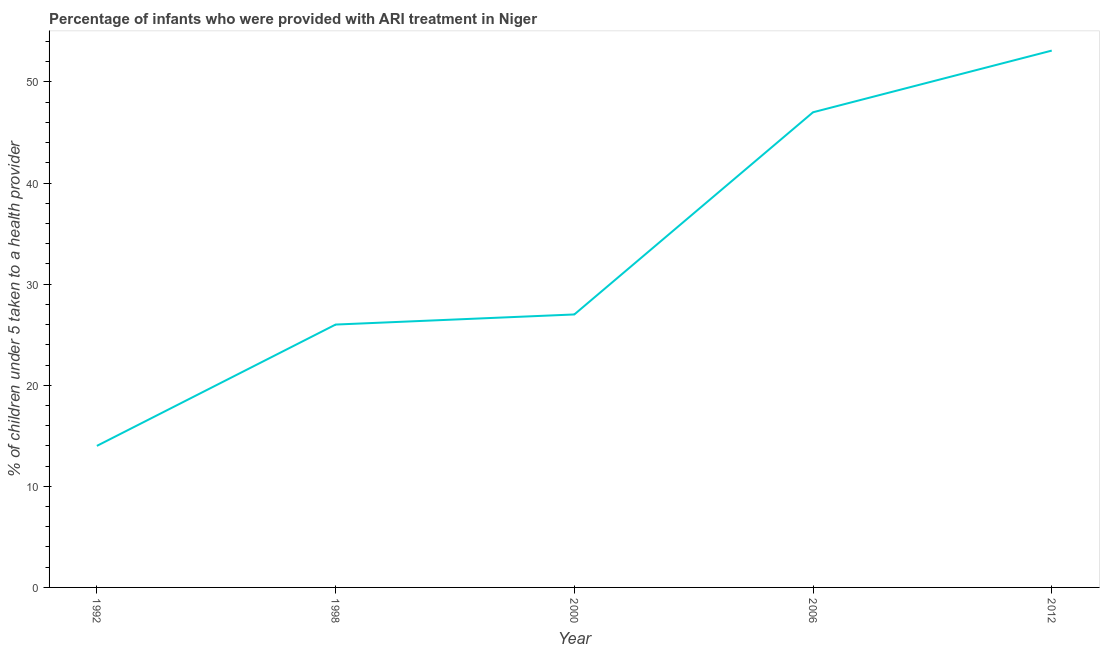Across all years, what is the maximum percentage of children who were provided with ari treatment?
Give a very brief answer. 53.1. In which year was the percentage of children who were provided with ari treatment maximum?
Give a very brief answer. 2012. In which year was the percentage of children who were provided with ari treatment minimum?
Provide a short and direct response. 1992. What is the sum of the percentage of children who were provided with ari treatment?
Keep it short and to the point. 167.1. What is the average percentage of children who were provided with ari treatment per year?
Your response must be concise. 33.42. Do a majority of the years between 2006 and 2012 (inclusive) have percentage of children who were provided with ari treatment greater than 18 %?
Provide a short and direct response. Yes. What is the ratio of the percentage of children who were provided with ari treatment in 2000 to that in 2006?
Ensure brevity in your answer.  0.57. What is the difference between the highest and the second highest percentage of children who were provided with ari treatment?
Your answer should be compact. 6.1. Is the sum of the percentage of children who were provided with ari treatment in 1998 and 2006 greater than the maximum percentage of children who were provided with ari treatment across all years?
Offer a very short reply. Yes. What is the difference between the highest and the lowest percentage of children who were provided with ari treatment?
Make the answer very short. 39.1. In how many years, is the percentage of children who were provided with ari treatment greater than the average percentage of children who were provided with ari treatment taken over all years?
Keep it short and to the point. 2. Does the percentage of children who were provided with ari treatment monotonically increase over the years?
Your response must be concise. Yes. How many lines are there?
Provide a short and direct response. 1. What is the difference between two consecutive major ticks on the Y-axis?
Make the answer very short. 10. Does the graph contain grids?
Provide a succinct answer. No. What is the title of the graph?
Offer a very short reply. Percentage of infants who were provided with ARI treatment in Niger. What is the label or title of the X-axis?
Ensure brevity in your answer.  Year. What is the label or title of the Y-axis?
Keep it short and to the point. % of children under 5 taken to a health provider. What is the % of children under 5 taken to a health provider in 1992?
Keep it short and to the point. 14. What is the % of children under 5 taken to a health provider of 1998?
Offer a terse response. 26. What is the % of children under 5 taken to a health provider of 2000?
Give a very brief answer. 27. What is the % of children under 5 taken to a health provider in 2006?
Ensure brevity in your answer.  47. What is the % of children under 5 taken to a health provider of 2012?
Offer a very short reply. 53.1. What is the difference between the % of children under 5 taken to a health provider in 1992 and 1998?
Your answer should be very brief. -12. What is the difference between the % of children under 5 taken to a health provider in 1992 and 2000?
Provide a short and direct response. -13. What is the difference between the % of children under 5 taken to a health provider in 1992 and 2006?
Keep it short and to the point. -33. What is the difference between the % of children under 5 taken to a health provider in 1992 and 2012?
Ensure brevity in your answer.  -39.1. What is the difference between the % of children under 5 taken to a health provider in 1998 and 2000?
Your response must be concise. -1. What is the difference between the % of children under 5 taken to a health provider in 1998 and 2006?
Keep it short and to the point. -21. What is the difference between the % of children under 5 taken to a health provider in 1998 and 2012?
Provide a short and direct response. -27.1. What is the difference between the % of children under 5 taken to a health provider in 2000 and 2006?
Your answer should be very brief. -20. What is the difference between the % of children under 5 taken to a health provider in 2000 and 2012?
Make the answer very short. -26.1. What is the ratio of the % of children under 5 taken to a health provider in 1992 to that in 1998?
Offer a terse response. 0.54. What is the ratio of the % of children under 5 taken to a health provider in 1992 to that in 2000?
Keep it short and to the point. 0.52. What is the ratio of the % of children under 5 taken to a health provider in 1992 to that in 2006?
Give a very brief answer. 0.3. What is the ratio of the % of children under 5 taken to a health provider in 1992 to that in 2012?
Provide a succinct answer. 0.26. What is the ratio of the % of children under 5 taken to a health provider in 1998 to that in 2006?
Give a very brief answer. 0.55. What is the ratio of the % of children under 5 taken to a health provider in 1998 to that in 2012?
Your answer should be compact. 0.49. What is the ratio of the % of children under 5 taken to a health provider in 2000 to that in 2006?
Provide a short and direct response. 0.57. What is the ratio of the % of children under 5 taken to a health provider in 2000 to that in 2012?
Offer a very short reply. 0.51. What is the ratio of the % of children under 5 taken to a health provider in 2006 to that in 2012?
Offer a very short reply. 0.89. 